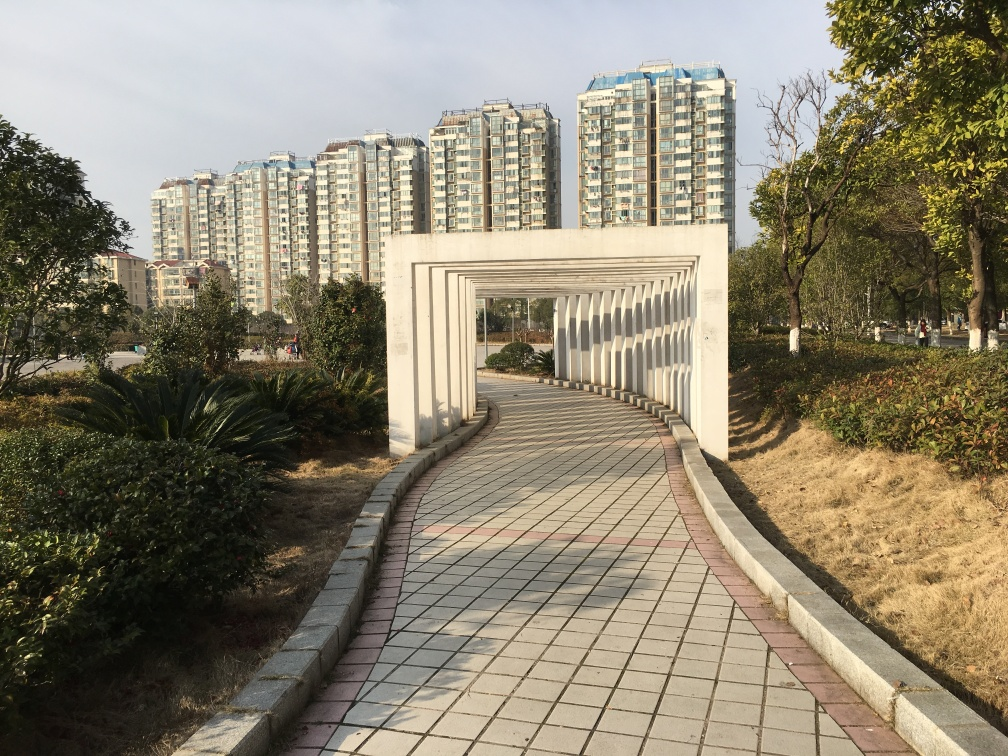What is the purpose of the white archway in the foreground? The white archway serves as a visually striking entrance that frames the path into the park, creating a sense of transition from one space to another and adding an element of design to the walking area. 